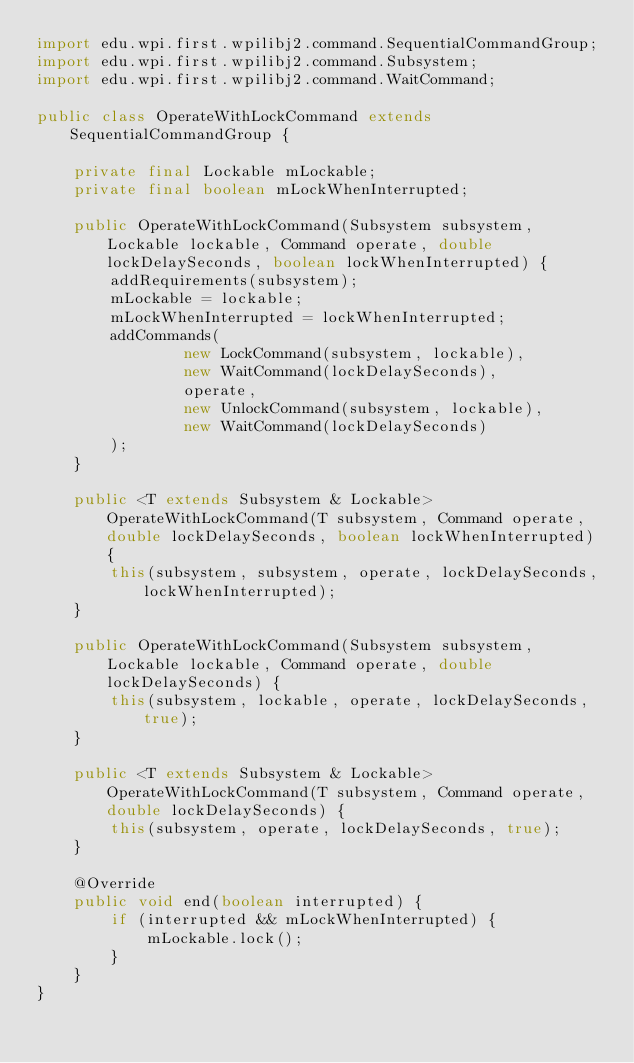Convert code to text. <code><loc_0><loc_0><loc_500><loc_500><_Java_>import edu.wpi.first.wpilibj2.command.SequentialCommandGroup;
import edu.wpi.first.wpilibj2.command.Subsystem;
import edu.wpi.first.wpilibj2.command.WaitCommand;

public class OperateWithLockCommand extends SequentialCommandGroup {

    private final Lockable mLockable;
    private final boolean mLockWhenInterrupted;

    public OperateWithLockCommand(Subsystem subsystem, Lockable lockable, Command operate, double lockDelaySeconds, boolean lockWhenInterrupted) {
        addRequirements(subsystem);
        mLockable = lockable;
        mLockWhenInterrupted = lockWhenInterrupted;
        addCommands(
                new LockCommand(subsystem, lockable),
                new WaitCommand(lockDelaySeconds),
                operate,
                new UnlockCommand(subsystem, lockable),
                new WaitCommand(lockDelaySeconds)
        );
    }

    public <T extends Subsystem & Lockable> OperateWithLockCommand(T subsystem, Command operate, double lockDelaySeconds, boolean lockWhenInterrupted) {
        this(subsystem, subsystem, operate, lockDelaySeconds, lockWhenInterrupted);
    }

    public OperateWithLockCommand(Subsystem subsystem, Lockable lockable, Command operate, double lockDelaySeconds) {
        this(subsystem, lockable, operate, lockDelaySeconds, true);
    }

    public <T extends Subsystem & Lockable> OperateWithLockCommand(T subsystem, Command operate, double lockDelaySeconds) {
        this(subsystem, operate, lockDelaySeconds, true);
    }

    @Override
    public void end(boolean interrupted) {
        if (interrupted && mLockWhenInterrupted) {
            mLockable.lock();
        }
    }
}
</code> 